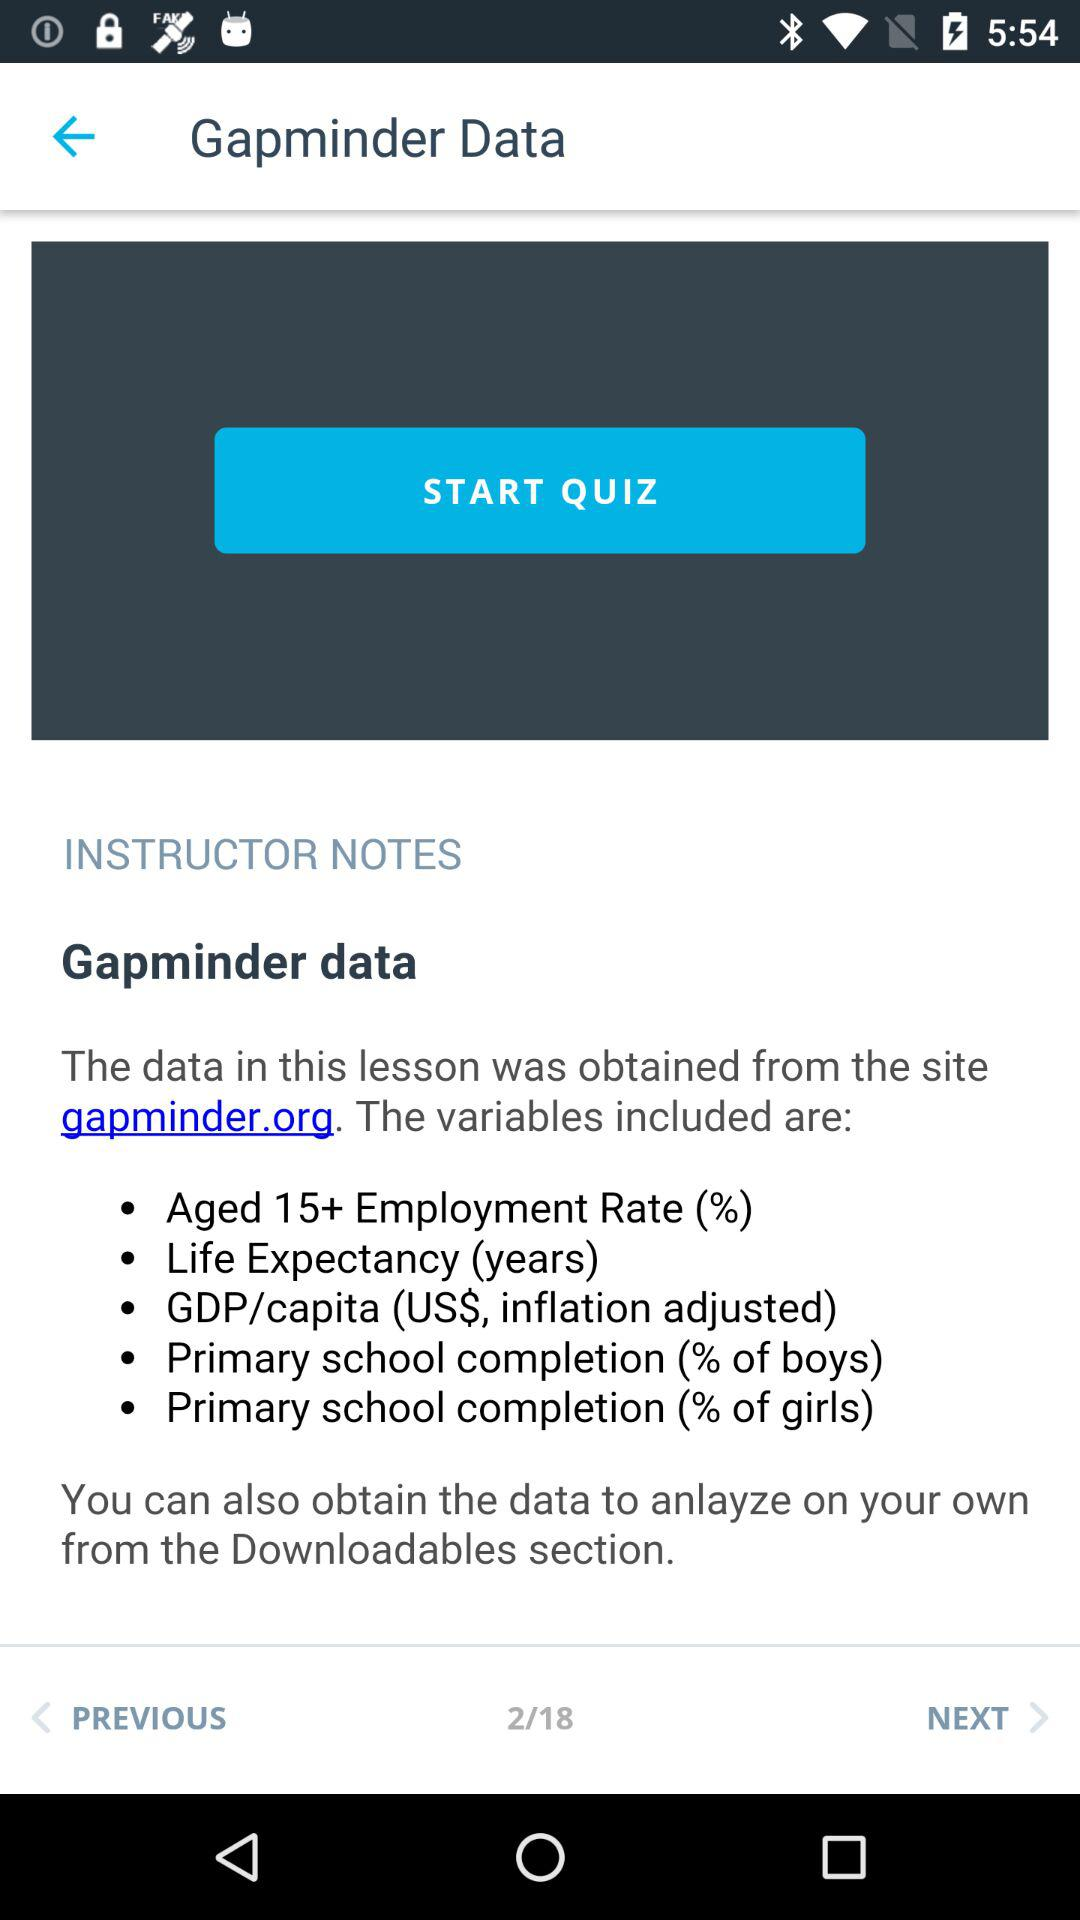How many total instructors?
When the provided information is insufficient, respond with <no answer>. <no answer> 